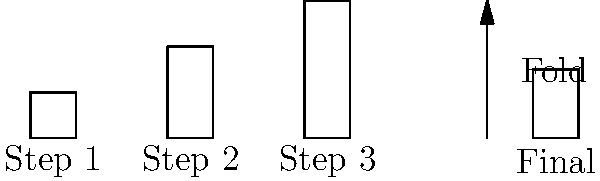The diagram shows a simplified representation of The Weeknd's hairstyle evolution as an origami folding process. If you were to mentally fold the paper following the arrow, which step's hairstyle would most closely resemble the final folded shape? Let's analyze this step-by-step:

1. Step 1 shows a short hairstyle, represented by a square.
2. Step 2 shows a medium-length hairstyle, represented by a rectangle twice as tall as the square.
3. Step 3 shows a long hairstyle, represented by a rectangle three times as tall as the square.
4. The arrow indicates a folding action, where the paper is folded in half horizontally.
5. The final shape is a rectangle with a height that's half of its original height.

To determine which step's hairstyle most closely resembles the final folded shape:
- If we fold Step 1, it would become a rectangle half as tall as its original height.
- If we fold Step 2, it would become a square (as its height was double its width).
- If we fold Step 3, it would become a rectangle 1.5 times as tall as it is wide.

Comparing these to the final shape shown, which is a rectangle with a height that's half of its original height, we can see that folding Step 2 would result in a shape most similar to the final folded shape.
Answer: Step 2 